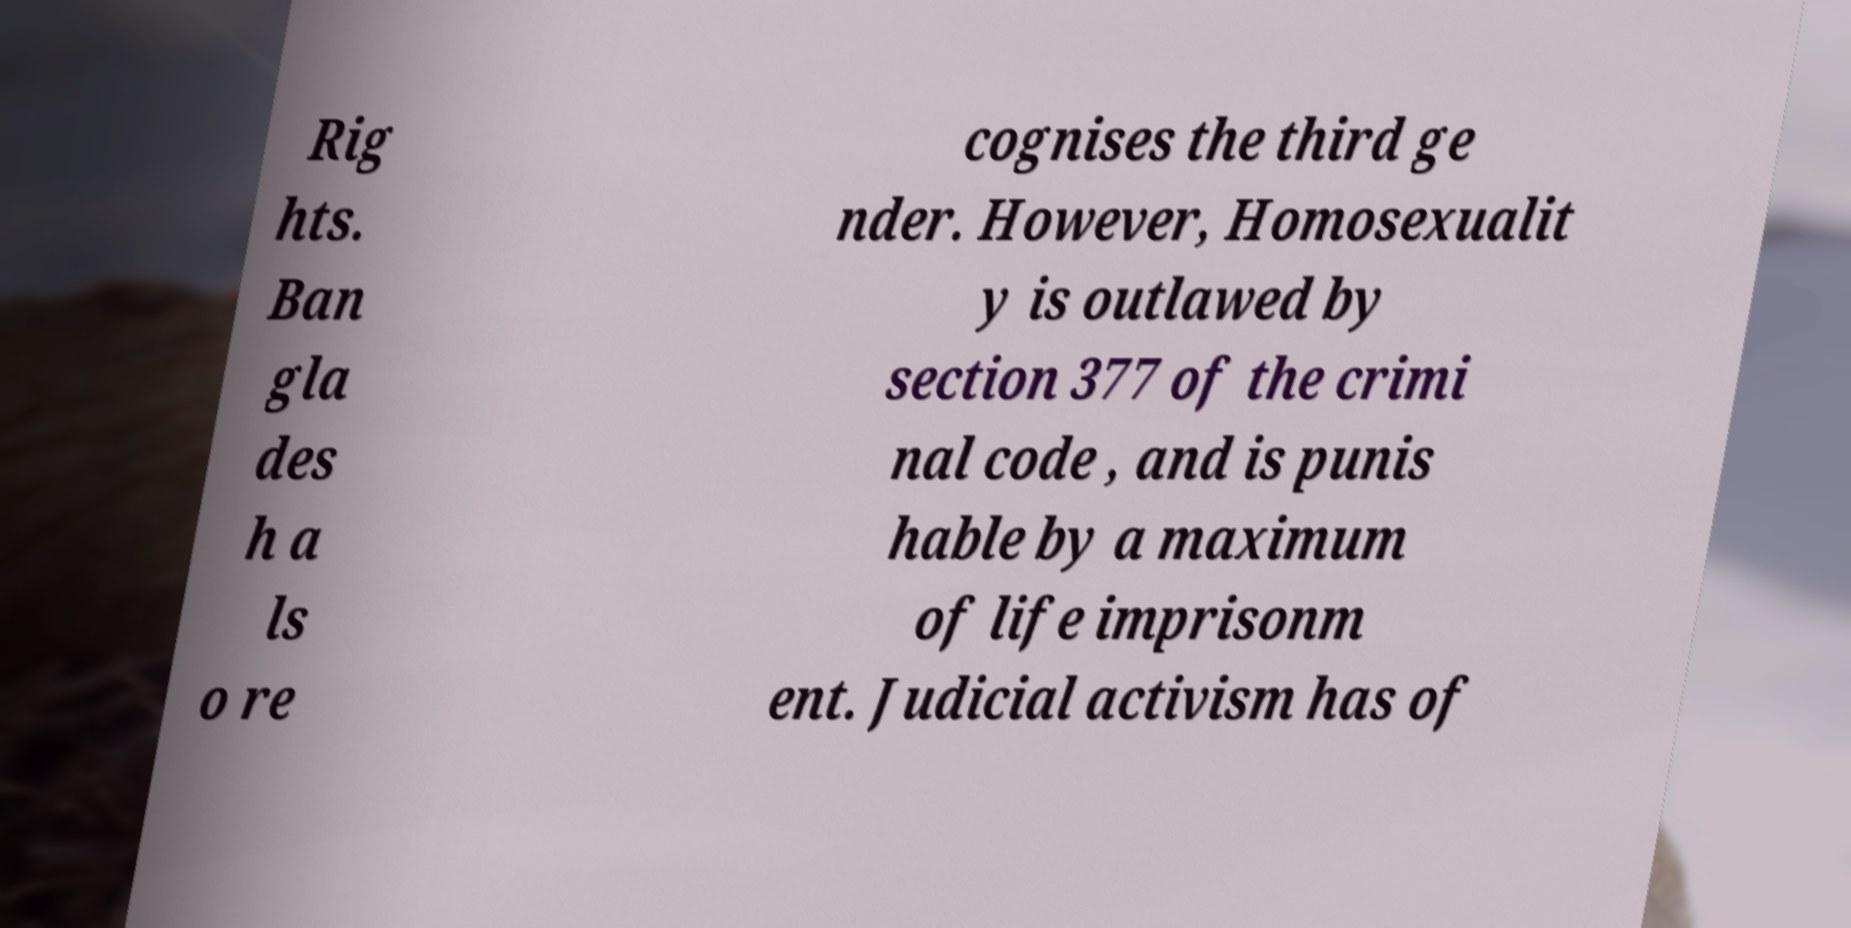What messages or text are displayed in this image? I need them in a readable, typed format. Rig hts. Ban gla des h a ls o re cognises the third ge nder. However, Homosexualit y is outlawed by section 377 of the crimi nal code , and is punis hable by a maximum of life imprisonm ent. Judicial activism has of 